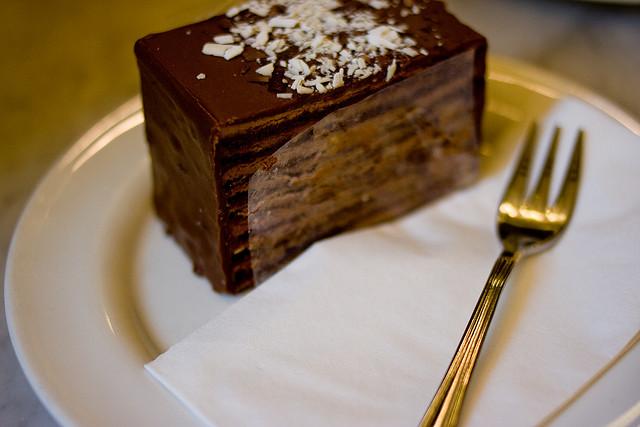How many layers are in this cake?
Keep it brief. 7. Does this cake look like it chocolate?
Keep it brief. Yes. How many people can eat this cake?
Quick response, please. 1. 